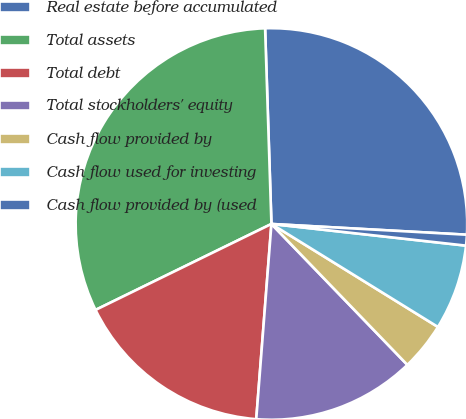Convert chart to OTSL. <chart><loc_0><loc_0><loc_500><loc_500><pie_chart><fcel>Real estate before accumulated<fcel>Total assets<fcel>Total debt<fcel>Total stockholders' equity<fcel>Cash flow provided by<fcel>Cash flow used for investing<fcel>Cash flow provided by (used<nl><fcel>26.39%<fcel>31.72%<fcel>16.53%<fcel>13.45%<fcel>3.97%<fcel>7.05%<fcel>0.89%<nl></chart> 